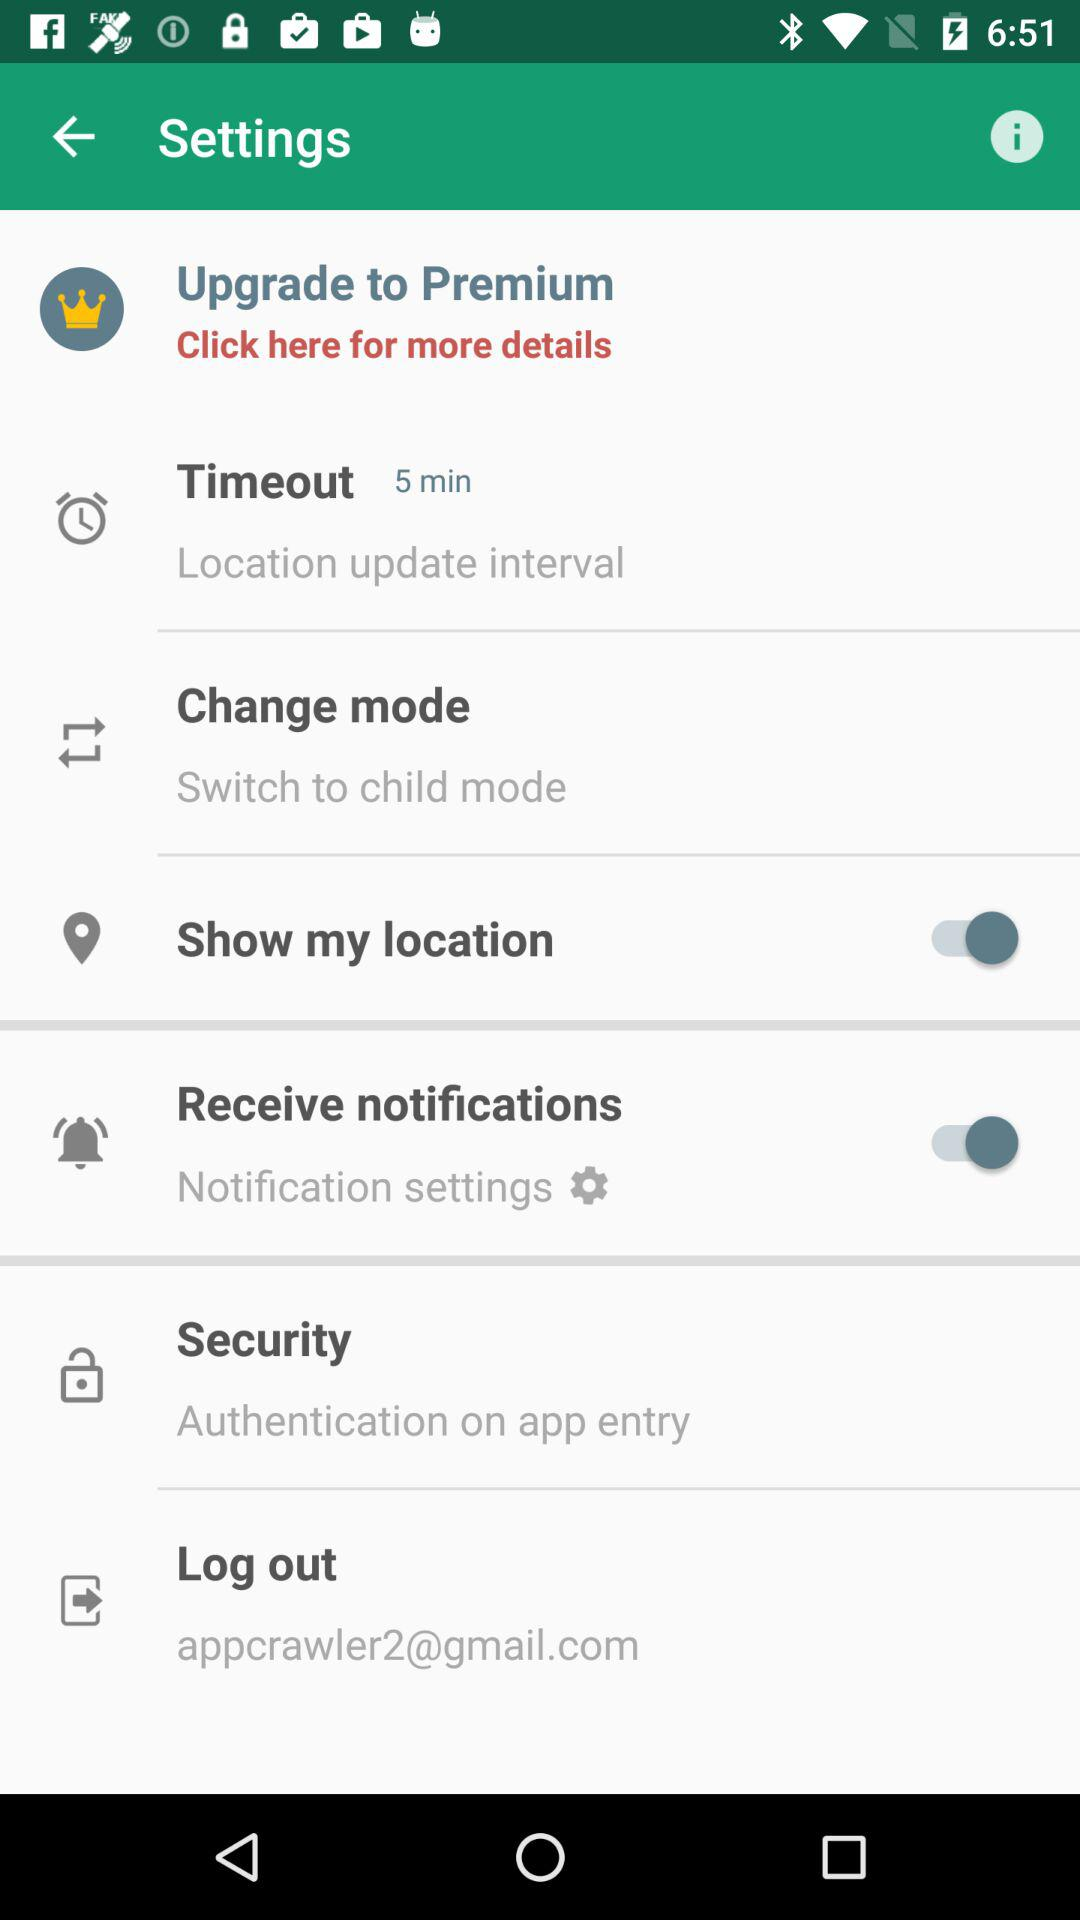What is the email address? The email address is appcrawler2@gmail.com. 